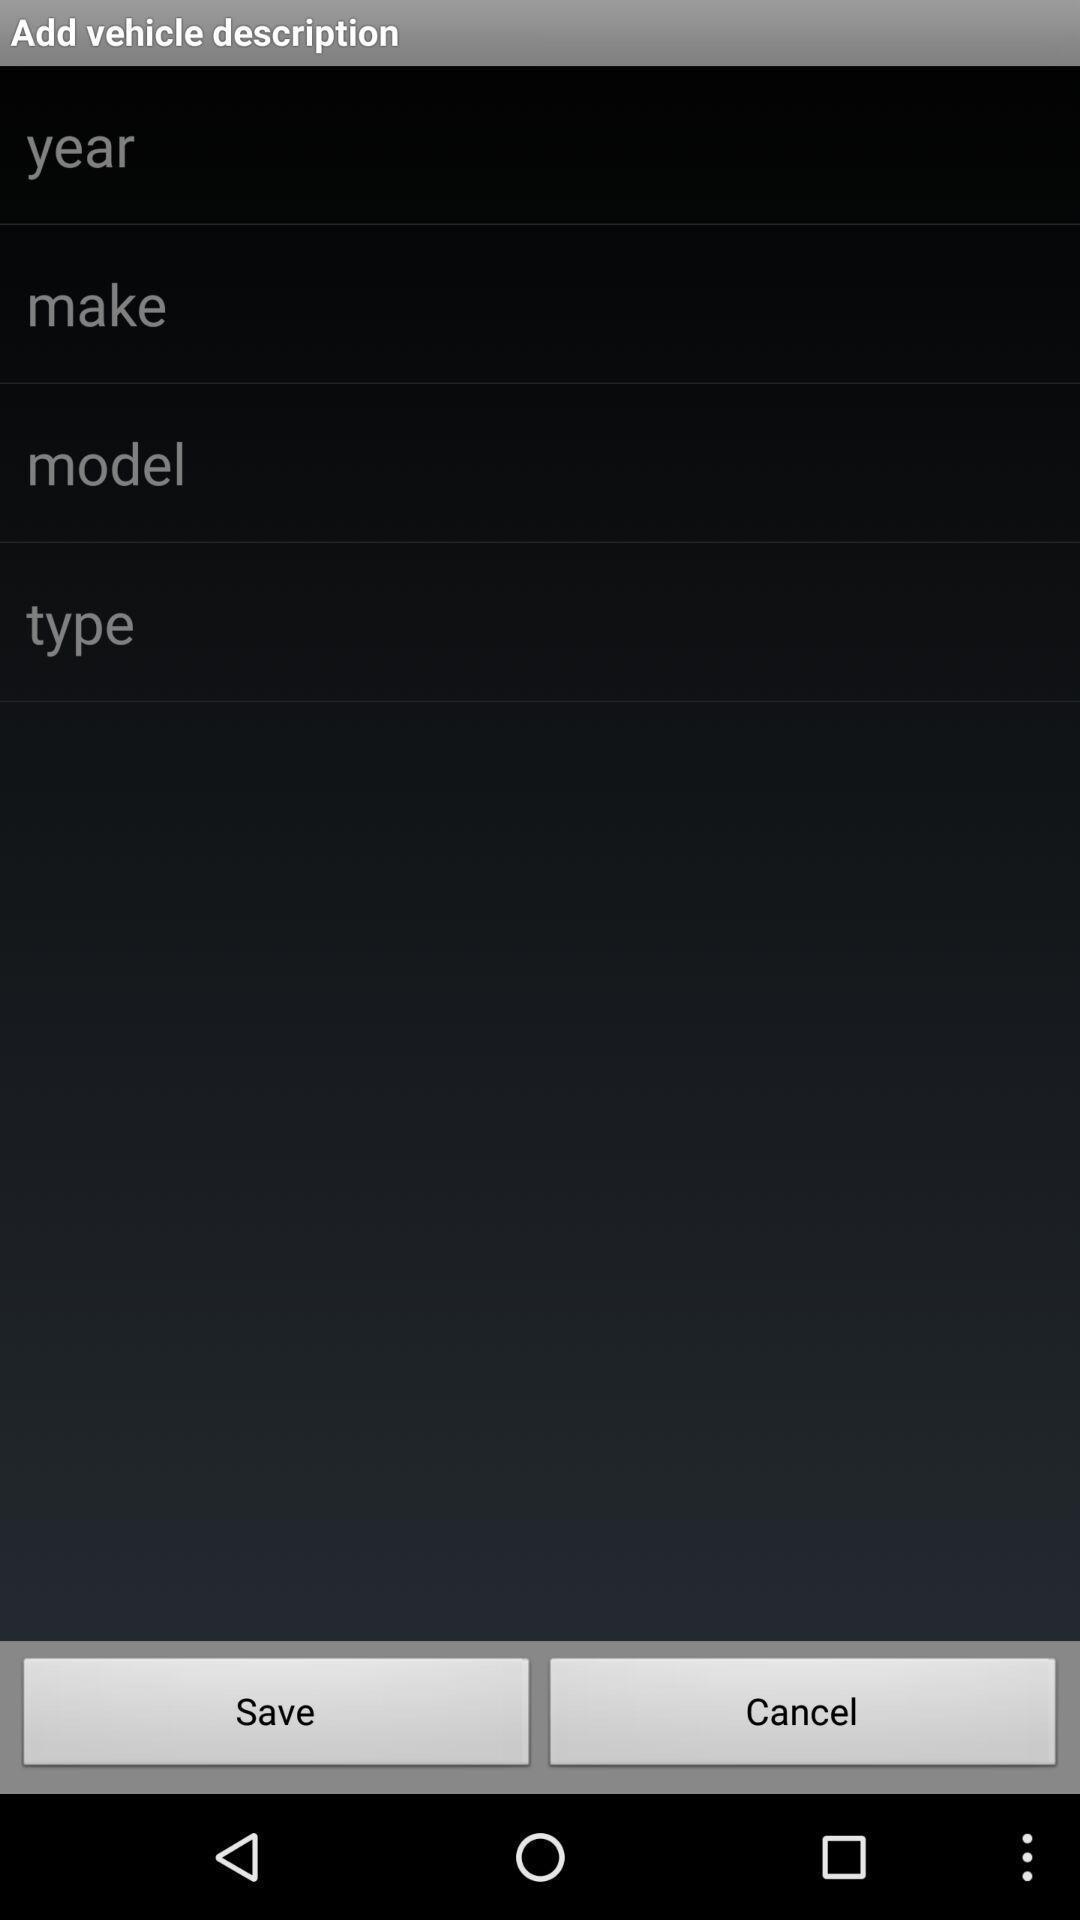Tell me about the visual elements in this screen capture. List of options in a vehicle performance control app. 